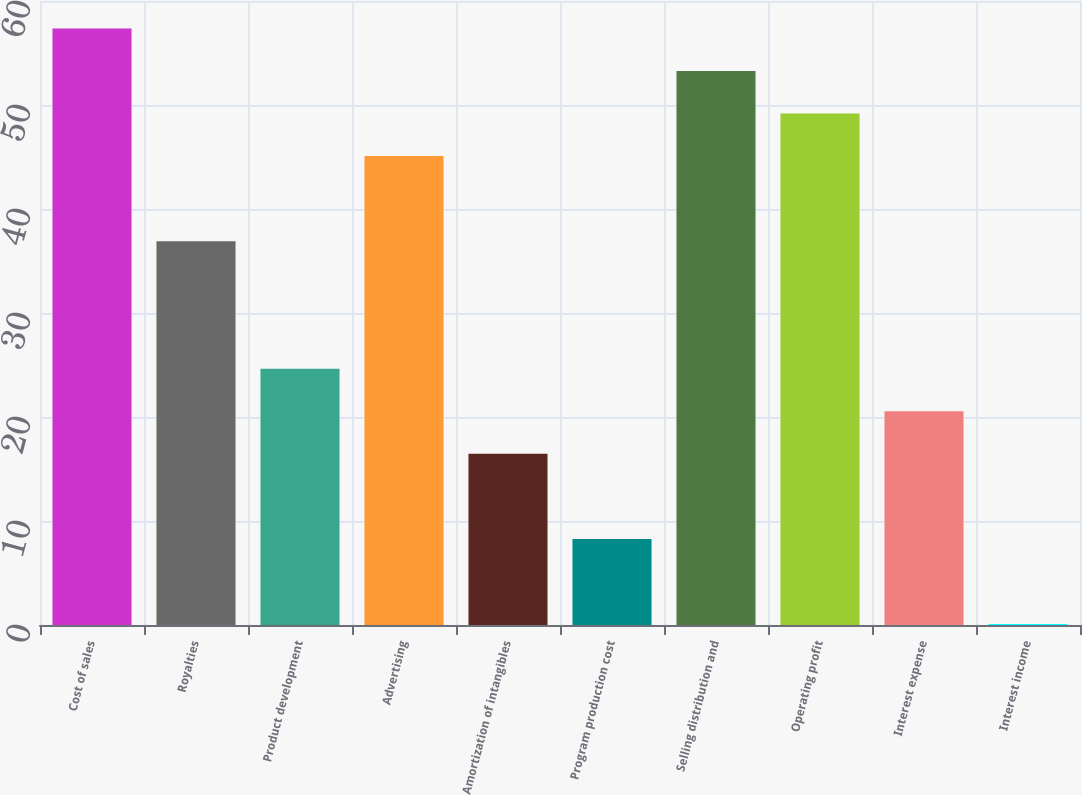Convert chart to OTSL. <chart><loc_0><loc_0><loc_500><loc_500><bar_chart><fcel>Cost of sales<fcel>Royalties<fcel>Product development<fcel>Advertising<fcel>Amortization of intangibles<fcel>Program production cost<fcel>Selling distribution and<fcel>Operating profit<fcel>Interest expense<fcel>Interest income<nl><fcel>57.36<fcel>36.91<fcel>24.64<fcel>45.09<fcel>16.46<fcel>8.28<fcel>53.27<fcel>49.18<fcel>20.55<fcel>0.1<nl></chart> 